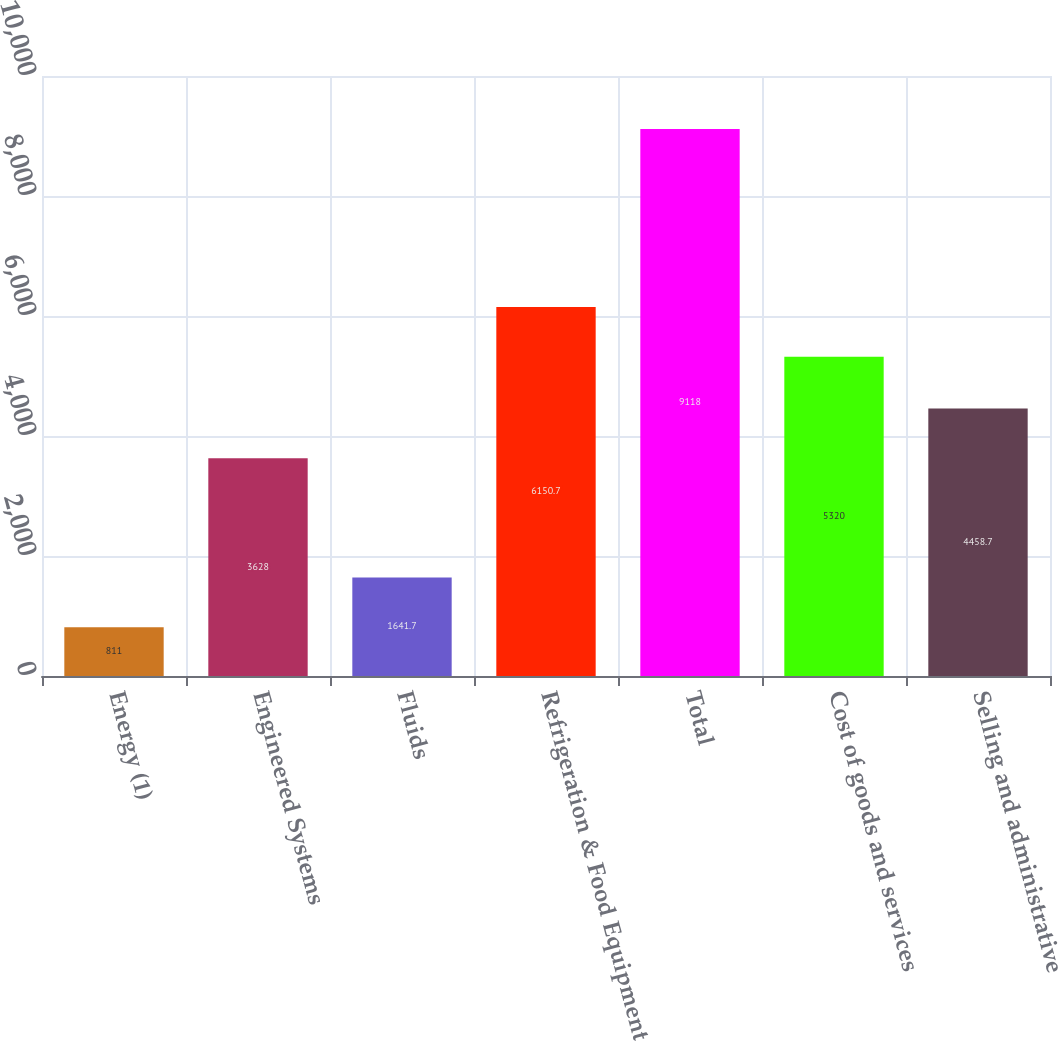<chart> <loc_0><loc_0><loc_500><loc_500><bar_chart><fcel>Energy (1)<fcel>Engineered Systems<fcel>Fluids<fcel>Refrigeration & Food Equipment<fcel>Total<fcel>Cost of goods and services<fcel>Selling and administrative<nl><fcel>811<fcel>3628<fcel>1641.7<fcel>6150.7<fcel>9118<fcel>5320<fcel>4458.7<nl></chart> 